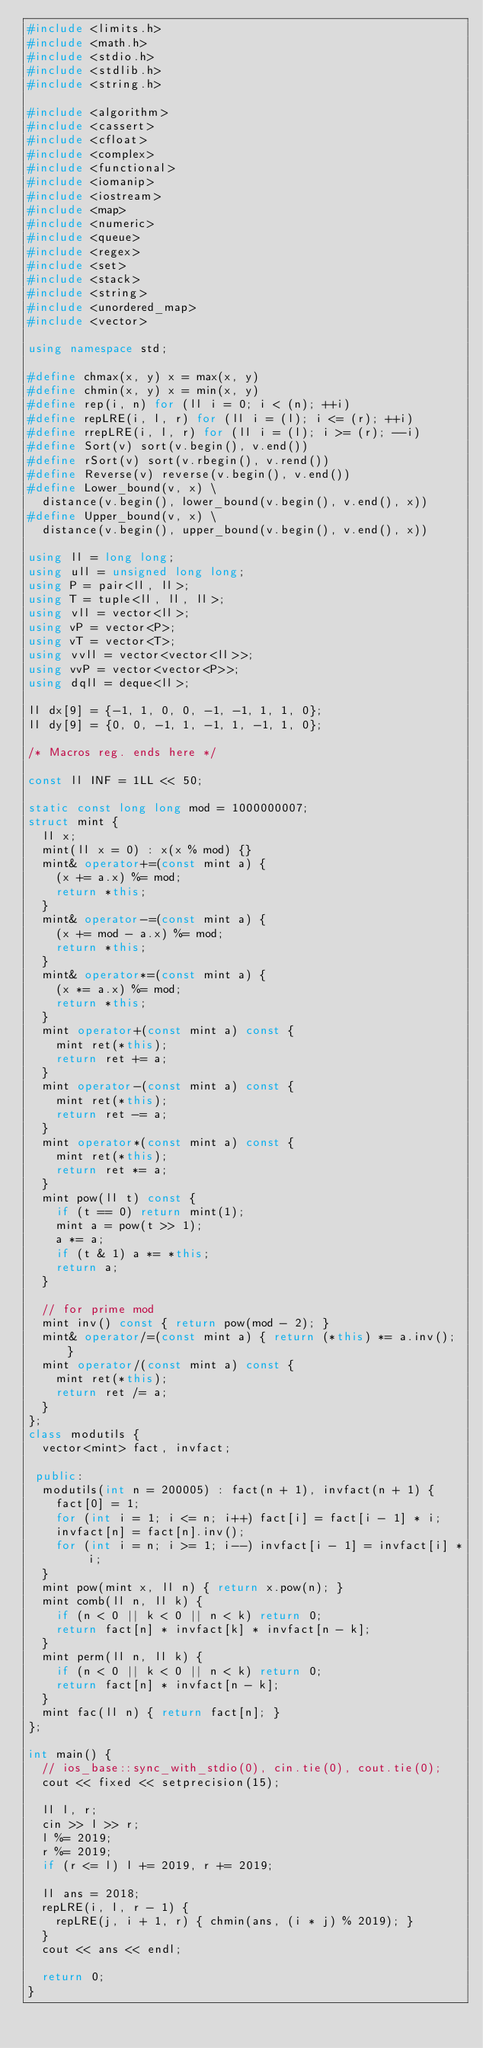<code> <loc_0><loc_0><loc_500><loc_500><_C++_>#include <limits.h>
#include <math.h>
#include <stdio.h>
#include <stdlib.h>
#include <string.h>

#include <algorithm>
#include <cassert>
#include <cfloat>
#include <complex>
#include <functional>
#include <iomanip>
#include <iostream>
#include <map>
#include <numeric>
#include <queue>
#include <regex>
#include <set>
#include <stack>
#include <string>
#include <unordered_map>
#include <vector>

using namespace std;

#define chmax(x, y) x = max(x, y)
#define chmin(x, y) x = min(x, y)
#define rep(i, n) for (ll i = 0; i < (n); ++i)
#define repLRE(i, l, r) for (ll i = (l); i <= (r); ++i)
#define rrepLRE(i, l, r) for (ll i = (l); i >= (r); --i)
#define Sort(v) sort(v.begin(), v.end())
#define rSort(v) sort(v.rbegin(), v.rend())
#define Reverse(v) reverse(v.begin(), v.end())
#define Lower_bound(v, x) \
  distance(v.begin(), lower_bound(v.begin(), v.end(), x))
#define Upper_bound(v, x) \
  distance(v.begin(), upper_bound(v.begin(), v.end(), x))

using ll = long long;
using ull = unsigned long long;
using P = pair<ll, ll>;
using T = tuple<ll, ll, ll>;
using vll = vector<ll>;
using vP = vector<P>;
using vT = vector<T>;
using vvll = vector<vector<ll>>;
using vvP = vector<vector<P>>;
using dqll = deque<ll>;

ll dx[9] = {-1, 1, 0, 0, -1, -1, 1, 1, 0};
ll dy[9] = {0, 0, -1, 1, -1, 1, -1, 1, 0};

/* Macros reg. ends here */

const ll INF = 1LL << 50;

static const long long mod = 1000000007;
struct mint {
  ll x;
  mint(ll x = 0) : x(x % mod) {}
  mint& operator+=(const mint a) {
    (x += a.x) %= mod;
    return *this;
  }
  mint& operator-=(const mint a) {
    (x += mod - a.x) %= mod;
    return *this;
  }
  mint& operator*=(const mint a) {
    (x *= a.x) %= mod;
    return *this;
  }
  mint operator+(const mint a) const {
    mint ret(*this);
    return ret += a;
  }
  mint operator-(const mint a) const {
    mint ret(*this);
    return ret -= a;
  }
  mint operator*(const mint a) const {
    mint ret(*this);
    return ret *= a;
  }
  mint pow(ll t) const {
    if (t == 0) return mint(1);
    mint a = pow(t >> 1);
    a *= a;
    if (t & 1) a *= *this;
    return a;
  }

  // for prime mod
  mint inv() const { return pow(mod - 2); }
  mint& operator/=(const mint a) { return (*this) *= a.inv(); }
  mint operator/(const mint a) const {
    mint ret(*this);
    return ret /= a;
  }
};
class modutils {
  vector<mint> fact, invfact;

 public:
  modutils(int n = 200005) : fact(n + 1), invfact(n + 1) {
    fact[0] = 1;
    for (int i = 1; i <= n; i++) fact[i] = fact[i - 1] * i;
    invfact[n] = fact[n].inv();
    for (int i = n; i >= 1; i--) invfact[i - 1] = invfact[i] * i;
  }
  mint pow(mint x, ll n) { return x.pow(n); }
  mint comb(ll n, ll k) {
    if (n < 0 || k < 0 || n < k) return 0;
    return fact[n] * invfact[k] * invfact[n - k];
  }
  mint perm(ll n, ll k) {
    if (n < 0 || k < 0 || n < k) return 0;
    return fact[n] * invfact[n - k];
  }
  mint fac(ll n) { return fact[n]; }
};

int main() {
  // ios_base::sync_with_stdio(0), cin.tie(0), cout.tie(0);
  cout << fixed << setprecision(15);

  ll l, r;
  cin >> l >> r;
  l %= 2019;
  r %= 2019;
  if (r <= l) l += 2019, r += 2019;

  ll ans = 2018;
  repLRE(i, l, r - 1) {
    repLRE(j, i + 1, r) { chmin(ans, (i * j) % 2019); }
  }
  cout << ans << endl;

  return 0;
}
</code> 